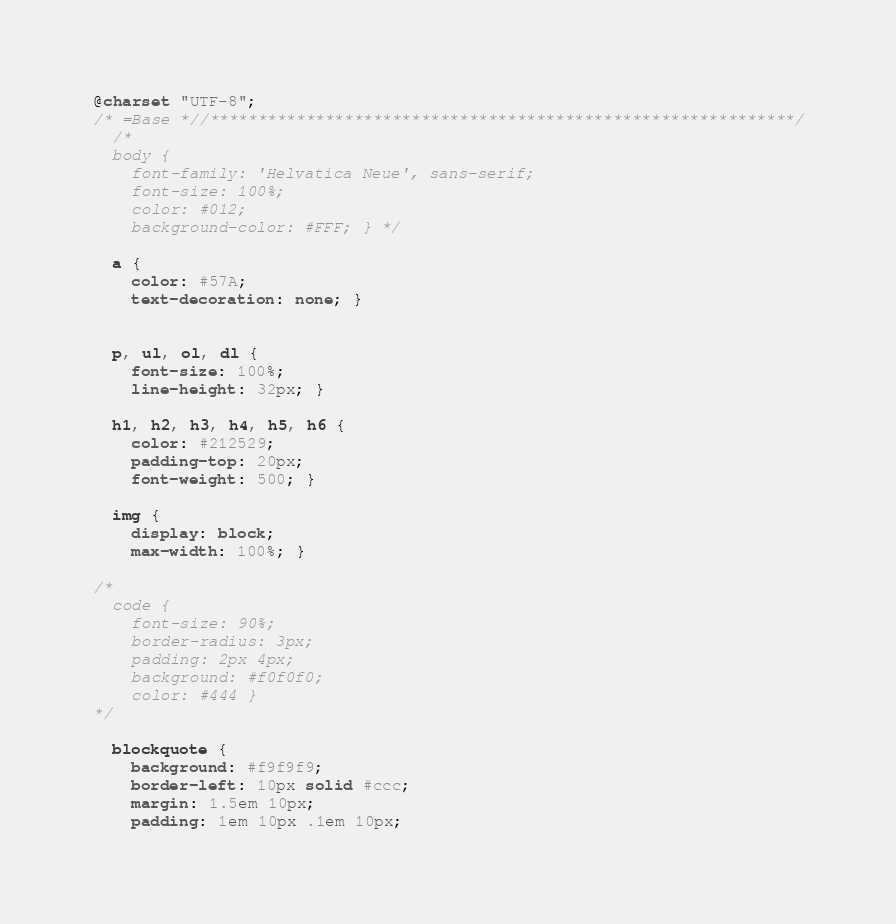<code> <loc_0><loc_0><loc_500><loc_500><_CSS_>@charset "UTF-8";
/* =Base *//*************************************************************/
  /*
  body {
    font-family: 'Helvatica Neue', sans-serif;
    font-size: 100%;
    color: #012;
    background-color: #FFF; } */

  a {
    color: #57A;
    text-decoration: none; }
  

  p, ul, ol, dl {
    font-size: 100%;
    line-height: 32px; }
  
  h1, h2, h3, h4, h5, h6 {
    color: #212529;
    padding-top: 20px;
    font-weight: 500; }

  img {
    display: block;
    max-width: 100%; }
  
/*  
  code {
    font-size: 90%;
    border-radius: 3px;
    padding: 2px 4px;
    background: #f0f0f0;
    color: #444 }
*/

  blockquote {
    background: #f9f9f9;
    border-left: 10px solid #ccc;
    margin: 1.5em 10px;
    padding: 1em 10px .1em 10px;</code> 